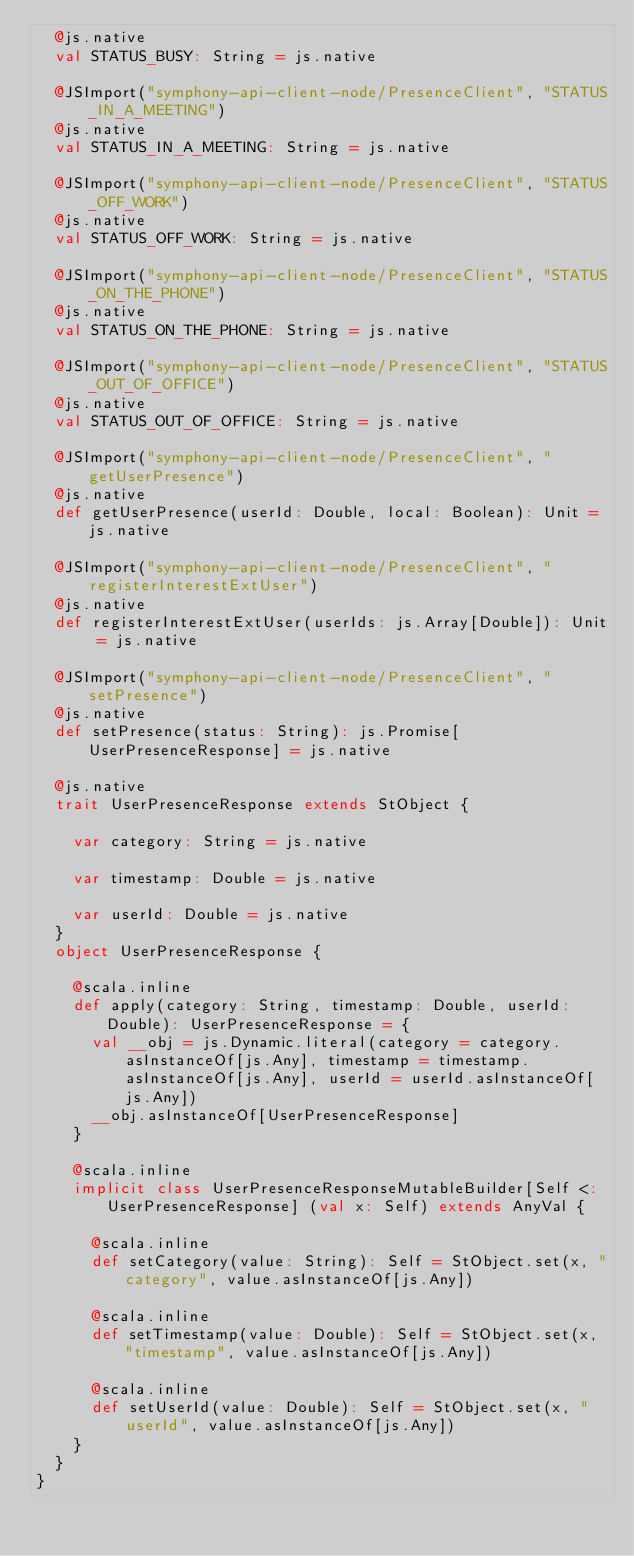<code> <loc_0><loc_0><loc_500><loc_500><_Scala_>  @js.native
  val STATUS_BUSY: String = js.native
  
  @JSImport("symphony-api-client-node/PresenceClient", "STATUS_IN_A_MEETING")
  @js.native
  val STATUS_IN_A_MEETING: String = js.native
  
  @JSImport("symphony-api-client-node/PresenceClient", "STATUS_OFF_WORK")
  @js.native
  val STATUS_OFF_WORK: String = js.native
  
  @JSImport("symphony-api-client-node/PresenceClient", "STATUS_ON_THE_PHONE")
  @js.native
  val STATUS_ON_THE_PHONE: String = js.native
  
  @JSImport("symphony-api-client-node/PresenceClient", "STATUS_OUT_OF_OFFICE")
  @js.native
  val STATUS_OUT_OF_OFFICE: String = js.native
  
  @JSImport("symphony-api-client-node/PresenceClient", "getUserPresence")
  @js.native
  def getUserPresence(userId: Double, local: Boolean): Unit = js.native
  
  @JSImport("symphony-api-client-node/PresenceClient", "registerInterestExtUser")
  @js.native
  def registerInterestExtUser(userIds: js.Array[Double]): Unit = js.native
  
  @JSImport("symphony-api-client-node/PresenceClient", "setPresence")
  @js.native
  def setPresence(status: String): js.Promise[UserPresenceResponse] = js.native
  
  @js.native
  trait UserPresenceResponse extends StObject {
    
    var category: String = js.native
    
    var timestamp: Double = js.native
    
    var userId: Double = js.native
  }
  object UserPresenceResponse {
    
    @scala.inline
    def apply(category: String, timestamp: Double, userId: Double): UserPresenceResponse = {
      val __obj = js.Dynamic.literal(category = category.asInstanceOf[js.Any], timestamp = timestamp.asInstanceOf[js.Any], userId = userId.asInstanceOf[js.Any])
      __obj.asInstanceOf[UserPresenceResponse]
    }
    
    @scala.inline
    implicit class UserPresenceResponseMutableBuilder[Self <: UserPresenceResponse] (val x: Self) extends AnyVal {
      
      @scala.inline
      def setCategory(value: String): Self = StObject.set(x, "category", value.asInstanceOf[js.Any])
      
      @scala.inline
      def setTimestamp(value: Double): Self = StObject.set(x, "timestamp", value.asInstanceOf[js.Any])
      
      @scala.inline
      def setUserId(value: Double): Self = StObject.set(x, "userId", value.asInstanceOf[js.Any])
    }
  }
}
</code> 